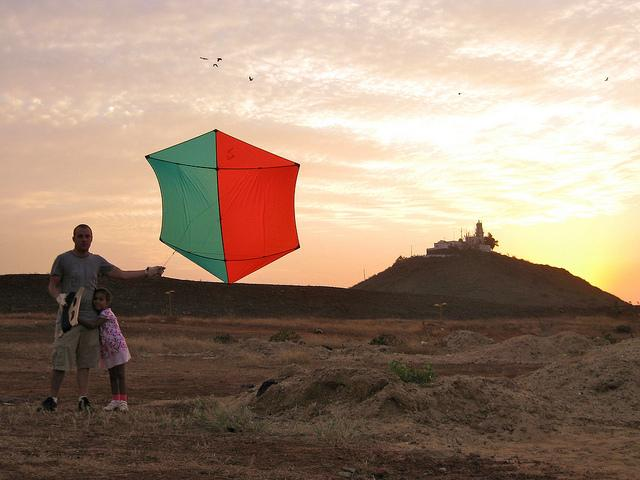What is on the item in the man's right hand? Please explain your reasoning. kite string. The kite is being held up by the string. 